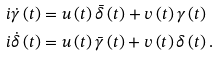<formula> <loc_0><loc_0><loc_500><loc_500>i \dot { \gamma } \left ( t \right ) & = u \left ( t \right ) \bar { \delta } \left ( t \right ) + v \left ( t \right ) \gamma \left ( t \right ) \\ i \dot { \delta } \left ( t \right ) & = u \left ( t \right ) \bar { \gamma } \left ( t \right ) + v \left ( t \right ) \delta \left ( t \right ) .</formula> 